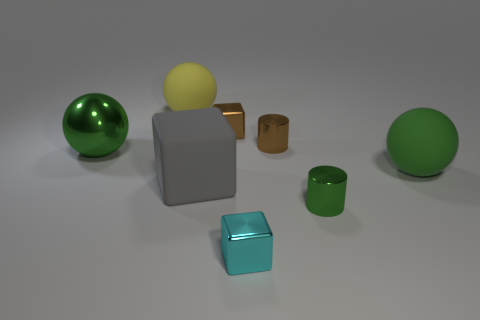Subtract all yellow rubber balls. How many balls are left? 2 Subtract all gray cylinders. How many green spheres are left? 2 Add 1 small green metallic objects. How many objects exist? 9 Subtract all spheres. How many objects are left? 5 Subtract all yellow cubes. Subtract all yellow balls. How many cubes are left? 3 Add 7 big green shiny balls. How many big green shiny balls are left? 8 Add 7 tiny brown things. How many tiny brown things exist? 9 Subtract 0 red spheres. How many objects are left? 8 Subtract all large green balls. Subtract all purple objects. How many objects are left? 6 